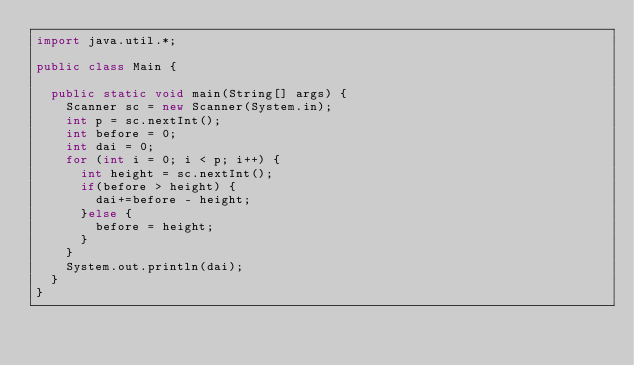<code> <loc_0><loc_0><loc_500><loc_500><_Java_>import java.util.*;

public class Main {

	public static void main(String[] args) {
		Scanner sc = new Scanner(System.in);
		int p = sc.nextInt();
		int before = 0;
		int dai = 0;
		for (int i = 0; i < p; i++) {
			int height = sc.nextInt();
			if(before > height) {
				dai+=before - height;
			}else {
				before = height;
			}
		}
		System.out.println(dai);
	}
}</code> 